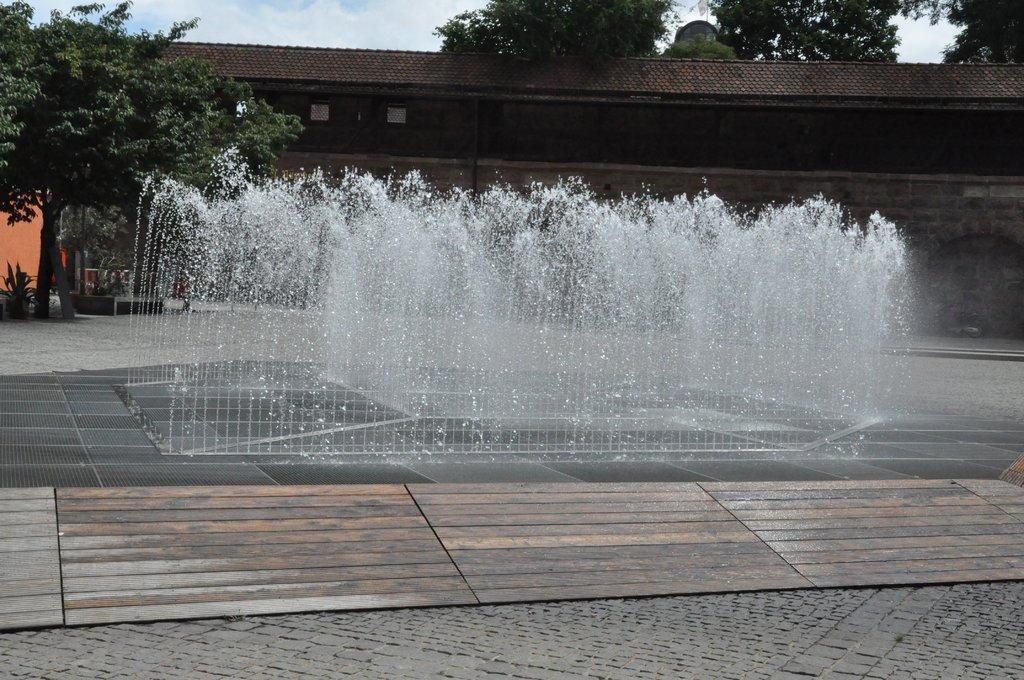How would you summarize this image in a sentence or two? In this picture there is fountain in the center of the image and there is a house in the background area of the image, there are trees at the top side of the image and on the left side of the image. 